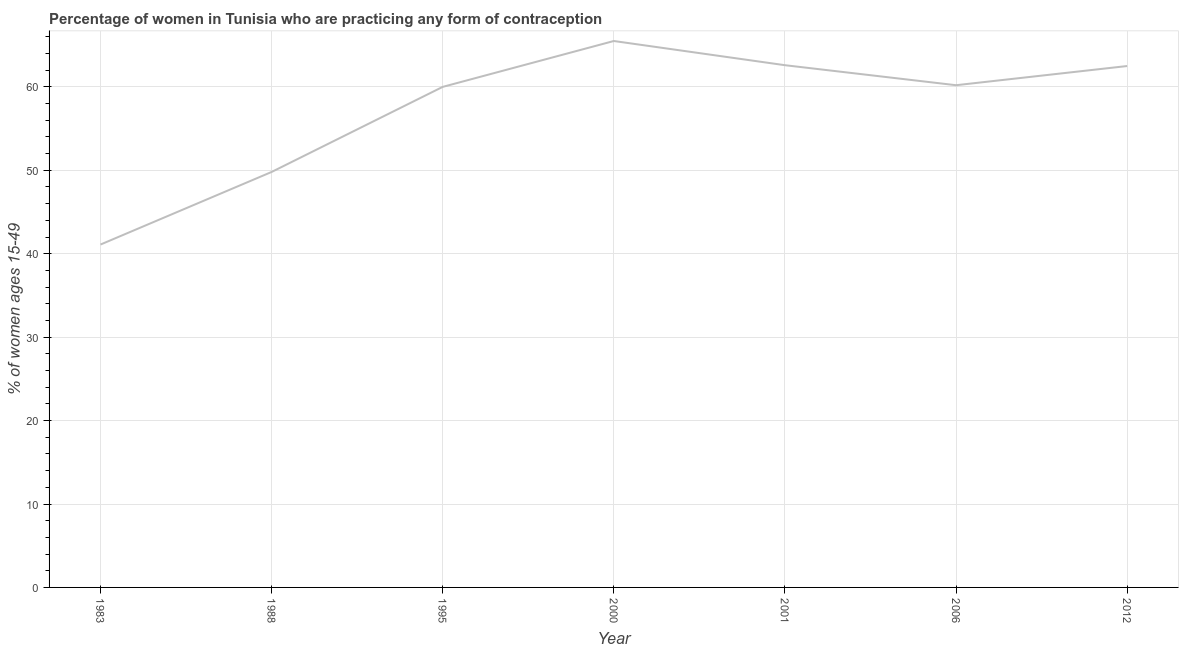What is the contraceptive prevalence in 2012?
Ensure brevity in your answer.  62.5. Across all years, what is the maximum contraceptive prevalence?
Ensure brevity in your answer.  65.5. Across all years, what is the minimum contraceptive prevalence?
Keep it short and to the point. 41.1. What is the sum of the contraceptive prevalence?
Your answer should be very brief. 401.7. What is the difference between the contraceptive prevalence in 1995 and 2006?
Keep it short and to the point. -0.2. What is the average contraceptive prevalence per year?
Your response must be concise. 57.39. What is the median contraceptive prevalence?
Your answer should be compact. 60.2. In how many years, is the contraceptive prevalence greater than 56 %?
Your response must be concise. 5. Do a majority of the years between 2001 and 2006 (inclusive) have contraceptive prevalence greater than 8 %?
Your response must be concise. Yes. What is the ratio of the contraceptive prevalence in 2001 to that in 2006?
Offer a very short reply. 1.04. What is the difference between the highest and the second highest contraceptive prevalence?
Keep it short and to the point. 2.9. What is the difference between the highest and the lowest contraceptive prevalence?
Your answer should be very brief. 24.4. Does the contraceptive prevalence monotonically increase over the years?
Make the answer very short. No. How many lines are there?
Give a very brief answer. 1. How many years are there in the graph?
Your answer should be compact. 7. What is the difference between two consecutive major ticks on the Y-axis?
Make the answer very short. 10. What is the title of the graph?
Your response must be concise. Percentage of women in Tunisia who are practicing any form of contraception. What is the label or title of the Y-axis?
Ensure brevity in your answer.  % of women ages 15-49. What is the % of women ages 15-49 in 1983?
Provide a short and direct response. 41.1. What is the % of women ages 15-49 of 1988?
Provide a short and direct response. 49.8. What is the % of women ages 15-49 in 2000?
Make the answer very short. 65.5. What is the % of women ages 15-49 of 2001?
Offer a terse response. 62.6. What is the % of women ages 15-49 in 2006?
Provide a short and direct response. 60.2. What is the % of women ages 15-49 in 2012?
Provide a short and direct response. 62.5. What is the difference between the % of women ages 15-49 in 1983 and 1995?
Offer a very short reply. -18.9. What is the difference between the % of women ages 15-49 in 1983 and 2000?
Provide a succinct answer. -24.4. What is the difference between the % of women ages 15-49 in 1983 and 2001?
Provide a short and direct response. -21.5. What is the difference between the % of women ages 15-49 in 1983 and 2006?
Provide a succinct answer. -19.1. What is the difference between the % of women ages 15-49 in 1983 and 2012?
Your response must be concise. -21.4. What is the difference between the % of women ages 15-49 in 1988 and 1995?
Keep it short and to the point. -10.2. What is the difference between the % of women ages 15-49 in 1988 and 2000?
Your answer should be compact. -15.7. What is the difference between the % of women ages 15-49 in 1988 and 2001?
Provide a short and direct response. -12.8. What is the difference between the % of women ages 15-49 in 1995 and 2000?
Keep it short and to the point. -5.5. What is the difference between the % of women ages 15-49 in 1995 and 2006?
Offer a very short reply. -0.2. What is the difference between the % of women ages 15-49 in 2000 and 2012?
Give a very brief answer. 3. What is the ratio of the % of women ages 15-49 in 1983 to that in 1988?
Your answer should be very brief. 0.82. What is the ratio of the % of women ages 15-49 in 1983 to that in 1995?
Offer a very short reply. 0.69. What is the ratio of the % of women ages 15-49 in 1983 to that in 2000?
Your response must be concise. 0.63. What is the ratio of the % of women ages 15-49 in 1983 to that in 2001?
Give a very brief answer. 0.66. What is the ratio of the % of women ages 15-49 in 1983 to that in 2006?
Provide a succinct answer. 0.68. What is the ratio of the % of women ages 15-49 in 1983 to that in 2012?
Your answer should be compact. 0.66. What is the ratio of the % of women ages 15-49 in 1988 to that in 1995?
Keep it short and to the point. 0.83. What is the ratio of the % of women ages 15-49 in 1988 to that in 2000?
Offer a very short reply. 0.76. What is the ratio of the % of women ages 15-49 in 1988 to that in 2001?
Provide a short and direct response. 0.8. What is the ratio of the % of women ages 15-49 in 1988 to that in 2006?
Make the answer very short. 0.83. What is the ratio of the % of women ages 15-49 in 1988 to that in 2012?
Provide a short and direct response. 0.8. What is the ratio of the % of women ages 15-49 in 1995 to that in 2000?
Keep it short and to the point. 0.92. What is the ratio of the % of women ages 15-49 in 1995 to that in 2001?
Your answer should be compact. 0.96. What is the ratio of the % of women ages 15-49 in 1995 to that in 2006?
Offer a very short reply. 1. What is the ratio of the % of women ages 15-49 in 1995 to that in 2012?
Keep it short and to the point. 0.96. What is the ratio of the % of women ages 15-49 in 2000 to that in 2001?
Provide a short and direct response. 1.05. What is the ratio of the % of women ages 15-49 in 2000 to that in 2006?
Keep it short and to the point. 1.09. What is the ratio of the % of women ages 15-49 in 2000 to that in 2012?
Keep it short and to the point. 1.05. What is the ratio of the % of women ages 15-49 in 2006 to that in 2012?
Ensure brevity in your answer.  0.96. 